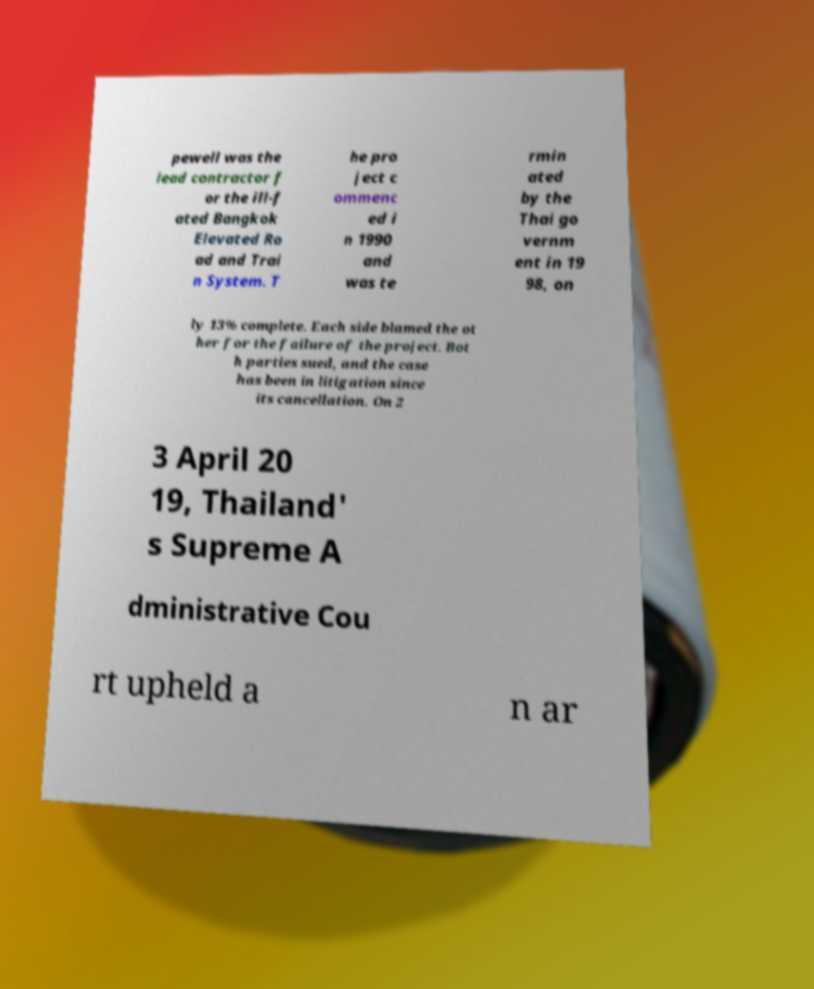There's text embedded in this image that I need extracted. Can you transcribe it verbatim? pewell was the lead contractor f or the ill-f ated Bangkok Elevated Ro ad and Trai n System. T he pro ject c ommenc ed i n 1990 and was te rmin ated by the Thai go vernm ent in 19 98, on ly 13% complete. Each side blamed the ot her for the failure of the project. Bot h parties sued, and the case has been in litigation since its cancellation. On 2 3 April 20 19, Thailand' s Supreme A dministrative Cou rt upheld a n ar 